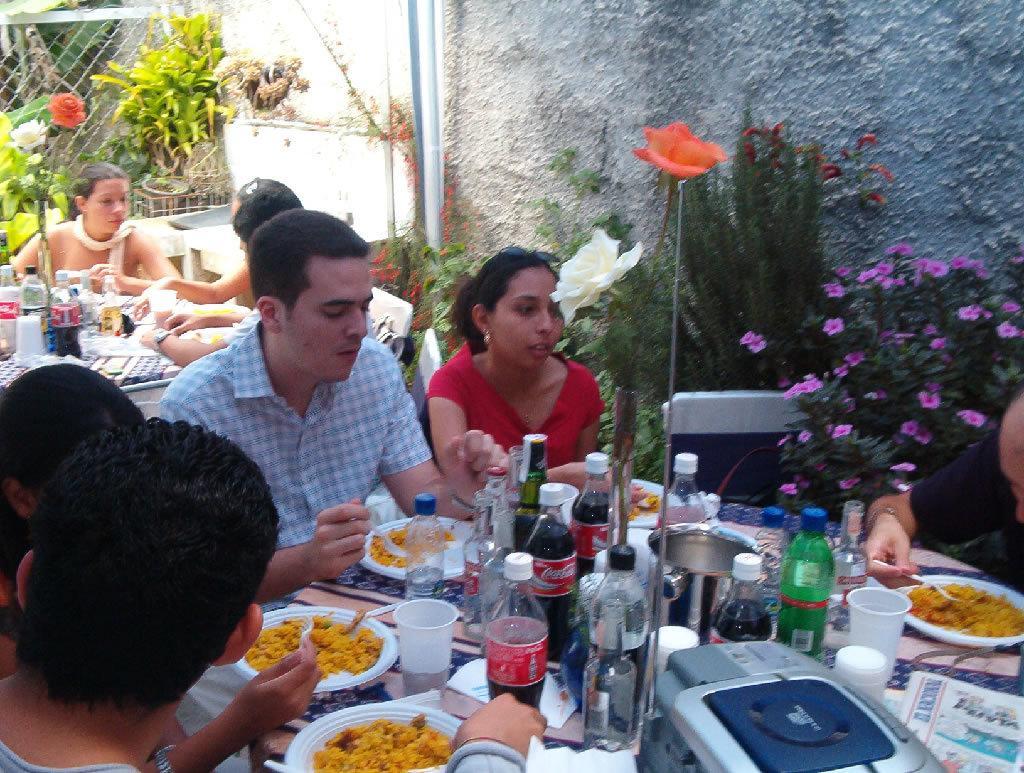Describe this image in one or two sentences. In the picture we can see a few people are sitting near the table and having the food and on the table, we can see some food items and some water bottles and behind the people we can see two people are sitting near another table and having something and beside them we can see some plants with flowers in it and in the background we can see the fencing. 